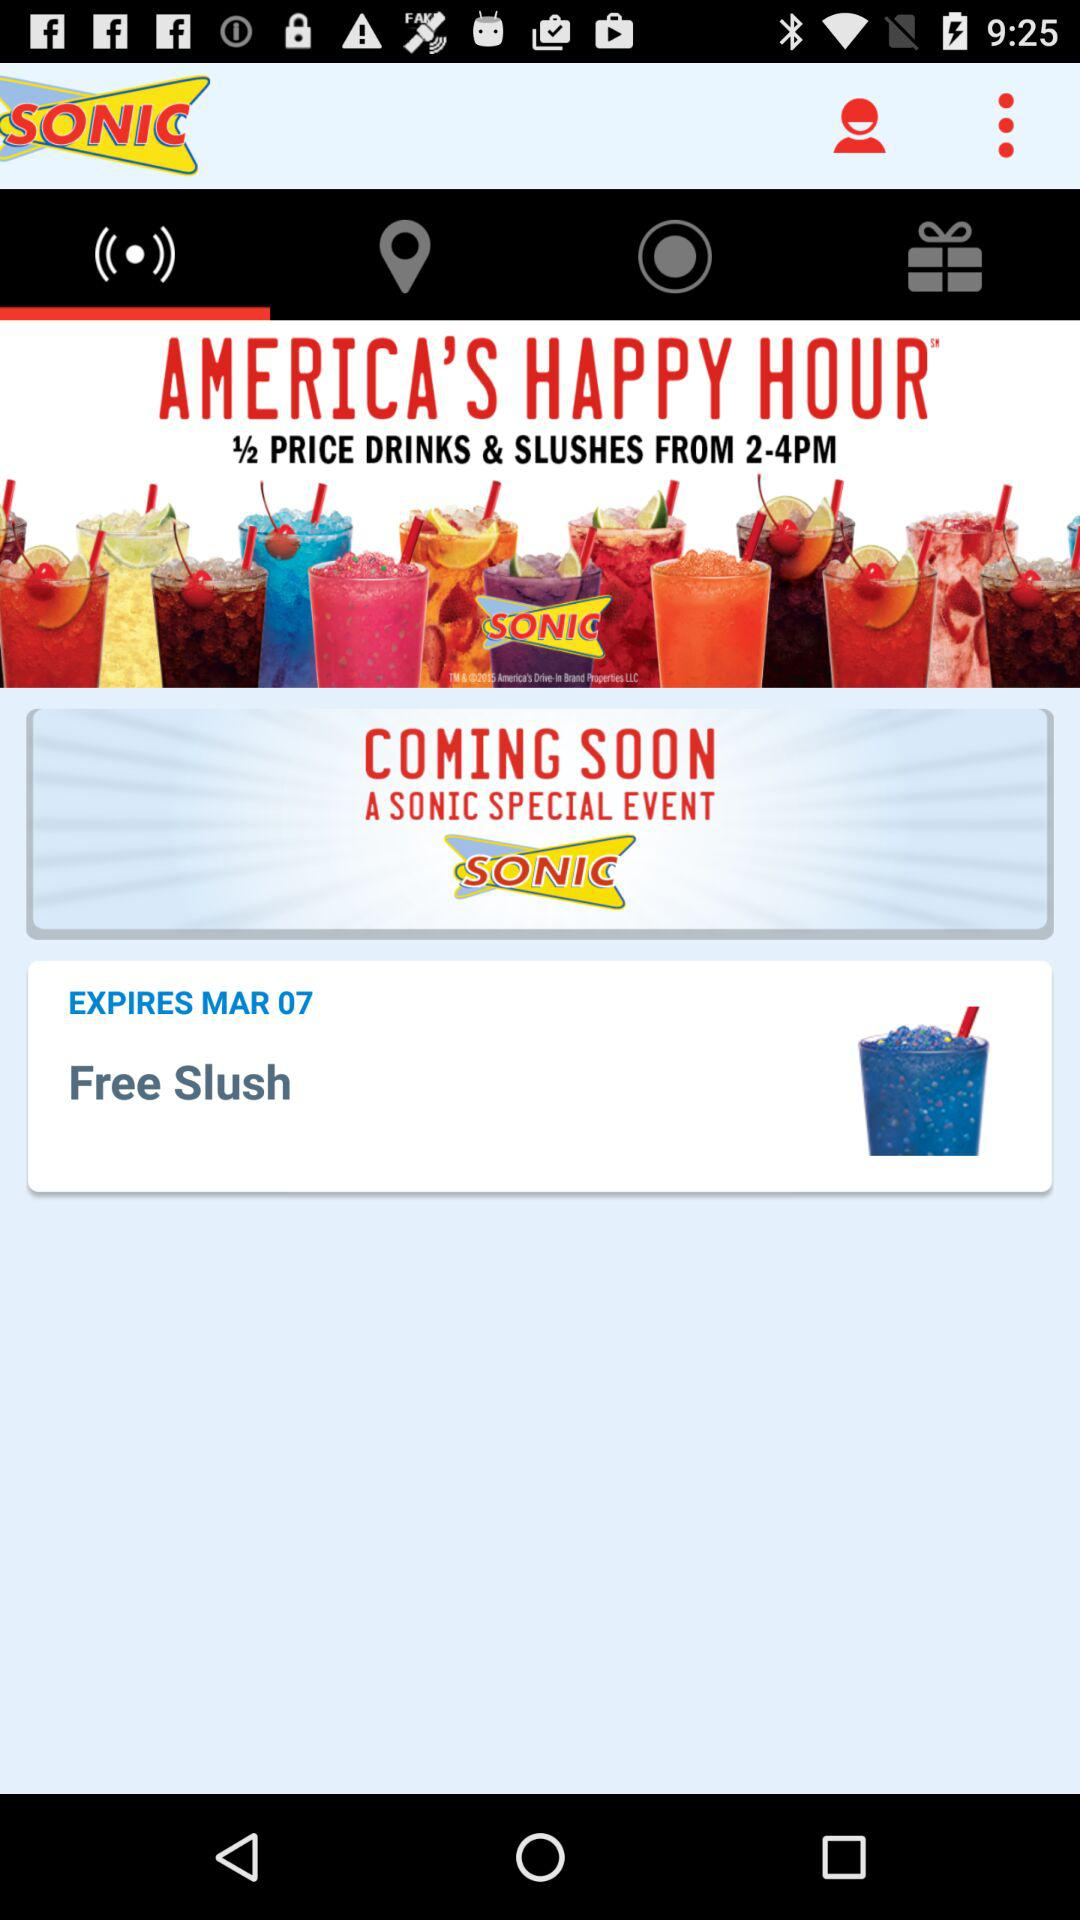What is the time of "AMERICA'S HAPPY HOUR"? The time is from 2 to 4 PM. 